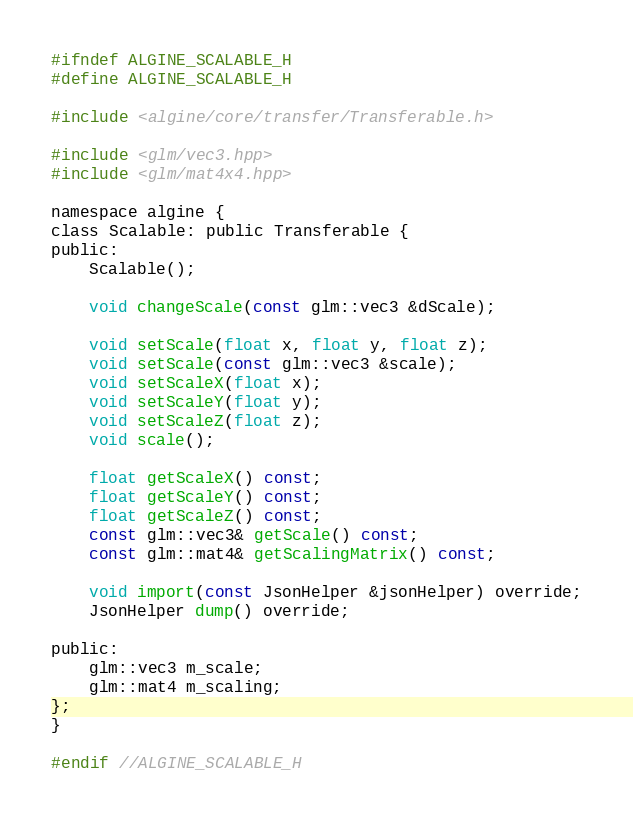Convert code to text. <code><loc_0><loc_0><loc_500><loc_500><_C_>#ifndef ALGINE_SCALABLE_H
#define ALGINE_SCALABLE_H

#include <algine/core/transfer/Transferable.h>

#include <glm/vec3.hpp>
#include <glm/mat4x4.hpp>

namespace algine {
class Scalable: public Transferable {
public:
    Scalable();

    void changeScale(const glm::vec3 &dScale);

    void setScale(float x, float y, float z);
    void setScale(const glm::vec3 &scale);
    void setScaleX(float x);
    void setScaleY(float y);
    void setScaleZ(float z);
    void scale();

    float getScaleX() const;
    float getScaleY() const;
    float getScaleZ() const;
    const glm::vec3& getScale() const;
    const glm::mat4& getScalingMatrix() const;

    void import(const JsonHelper &jsonHelper) override;
    JsonHelper dump() override;

public:
    glm::vec3 m_scale;
    glm::mat4 m_scaling;
};
}

#endif //ALGINE_SCALABLE_H
</code> 